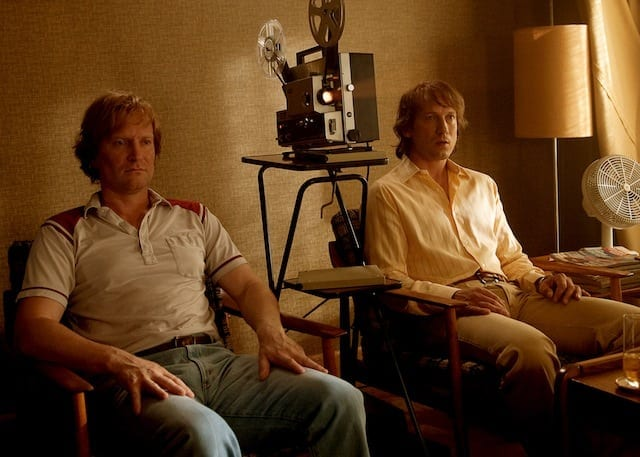What is this photo about? In this image, two individuals are captured in a seemingly relaxed setting. On the left side of the frame, a man is seated, casually dressed in a red and white striped shirt paired with blue jeans. His relaxed posture suggests a moment of leisure. Opposite him, on the right side of the image, another individual is also seated, donning a yellow shirt and blue jeans, mirroring the casual attire of the first person. The background features a film projector and a lamp, hinting at a cinematic or retro setting. The warm and muted color scheme adds to the intimate and nostalgic vibe of the scene, potentially capturing a behind-the-scenes moment or a scene from a movie. 